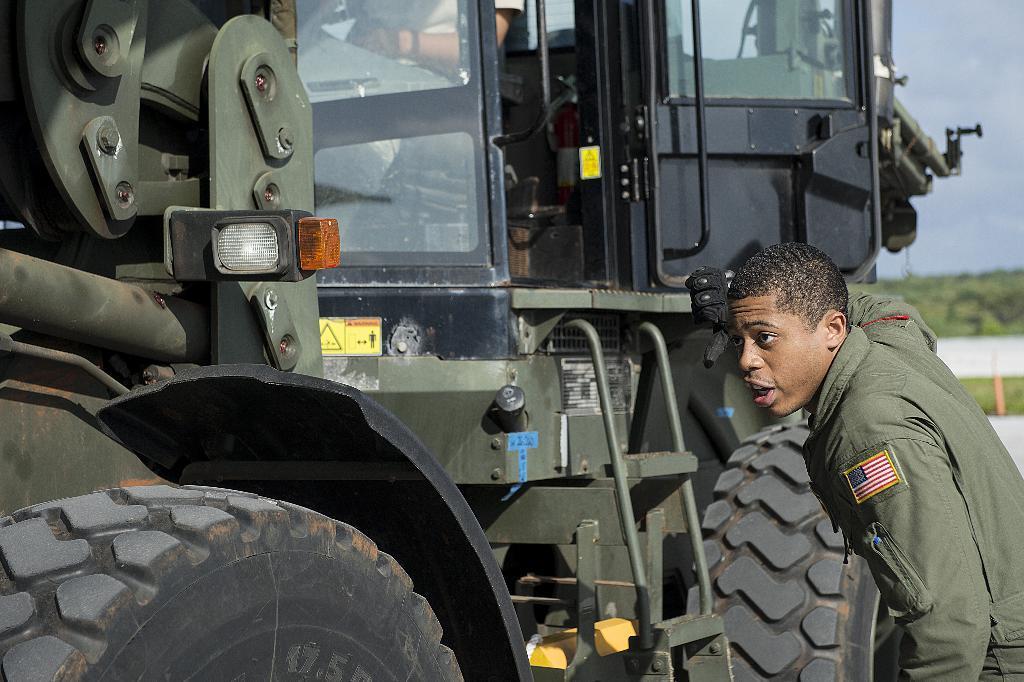How would you summarize this image in a sentence or two? In this image I can see a vehicle and in the vehicle I can see a person sitting and beside the vehicle I can see a person and the sky 